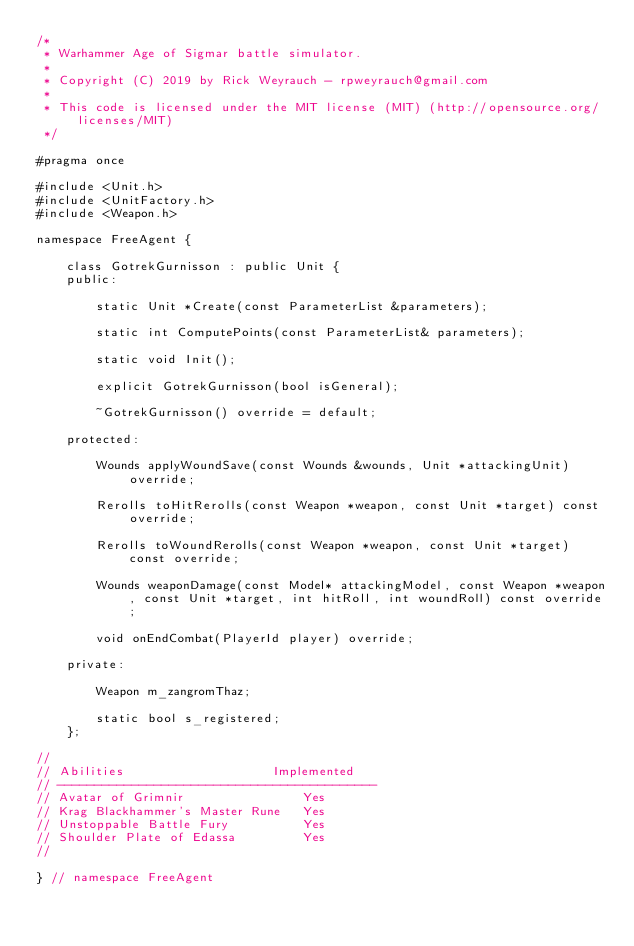<code> <loc_0><loc_0><loc_500><loc_500><_C_>/*
 * Warhammer Age of Sigmar battle simulator.
 *
 * Copyright (C) 2019 by Rick Weyrauch - rpweyrauch@gmail.com
 *
 * This code is licensed under the MIT license (MIT) (http://opensource.org/licenses/MIT)
 */

#pragma once

#include <Unit.h>
#include <UnitFactory.h>
#include <Weapon.h>

namespace FreeAgent {

    class GotrekGurnisson : public Unit {
    public:

        static Unit *Create(const ParameterList &parameters);

        static int ComputePoints(const ParameterList& parameters);

        static void Init();

        explicit GotrekGurnisson(bool isGeneral);

        ~GotrekGurnisson() override = default;

    protected:

        Wounds applyWoundSave(const Wounds &wounds, Unit *attackingUnit) override;

        Rerolls toHitRerolls(const Weapon *weapon, const Unit *target) const override;

        Rerolls toWoundRerolls(const Weapon *weapon, const Unit *target) const override;

        Wounds weaponDamage(const Model* attackingModel, const Weapon *weapon, const Unit *target, int hitRoll, int woundRoll) const override;

        void onEndCombat(PlayerId player) override;

    private:

        Weapon m_zangromThaz;

        static bool s_registered;
    };

//
// Abilities                    Implemented
// -------------------------------------------
// Avatar of Grimnir                Yes
// Krag Blackhammer's Master Rune   Yes
// Unstoppable Battle Fury          Yes
// Shoulder Plate of Edassa         Yes
//

} // namespace FreeAgent
</code> 